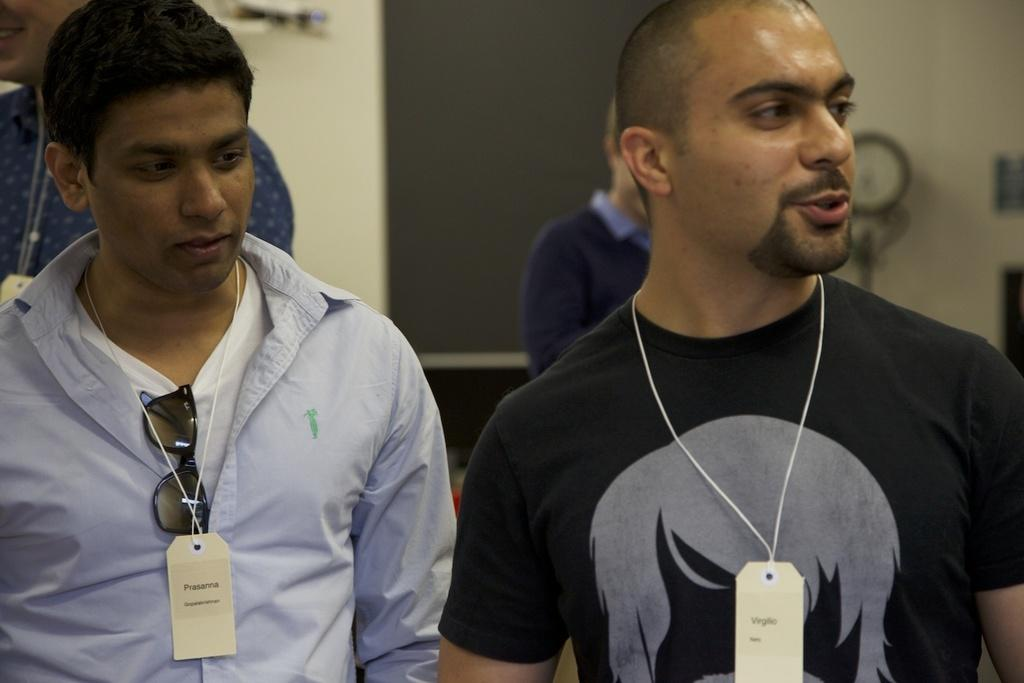How many people are in the image? There is a group of people in the image, but the exact number is not specified. What are the people wearing that helps identify them? The people are wearing tags in the image. Can you describe the appearance of one person in the group? There is a person with goggles in the image. What can be seen in the background of the image? There is a wall and blurred objects in the background of the image. What type of dust can be seen on the celery in the image? There is no celery or dust present in the image. What time is displayed on the watch in the image? There is no watch present in the image. 